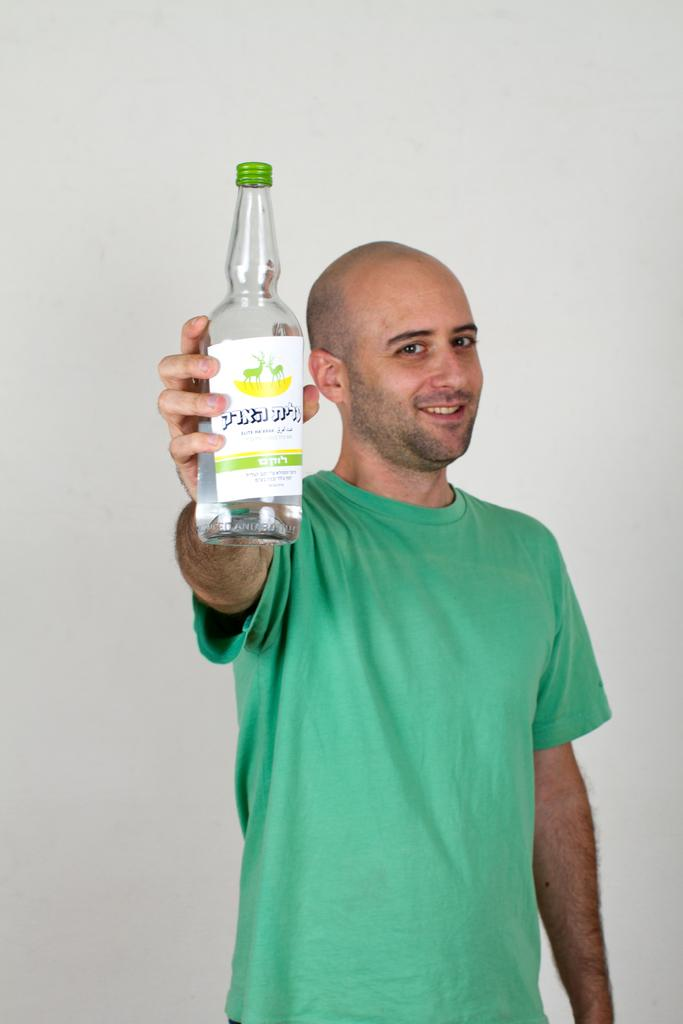Who is present in the image? There is a man in the image. What is the man's facial expression? The man is smiling. What is the man holding in his hand? The man is holding a bottle in his hand. What type of stitch is the man using to sew the crib in the image? There is no crib or stitching activity present in the image; it only features a man holding a bottle and smiling. 